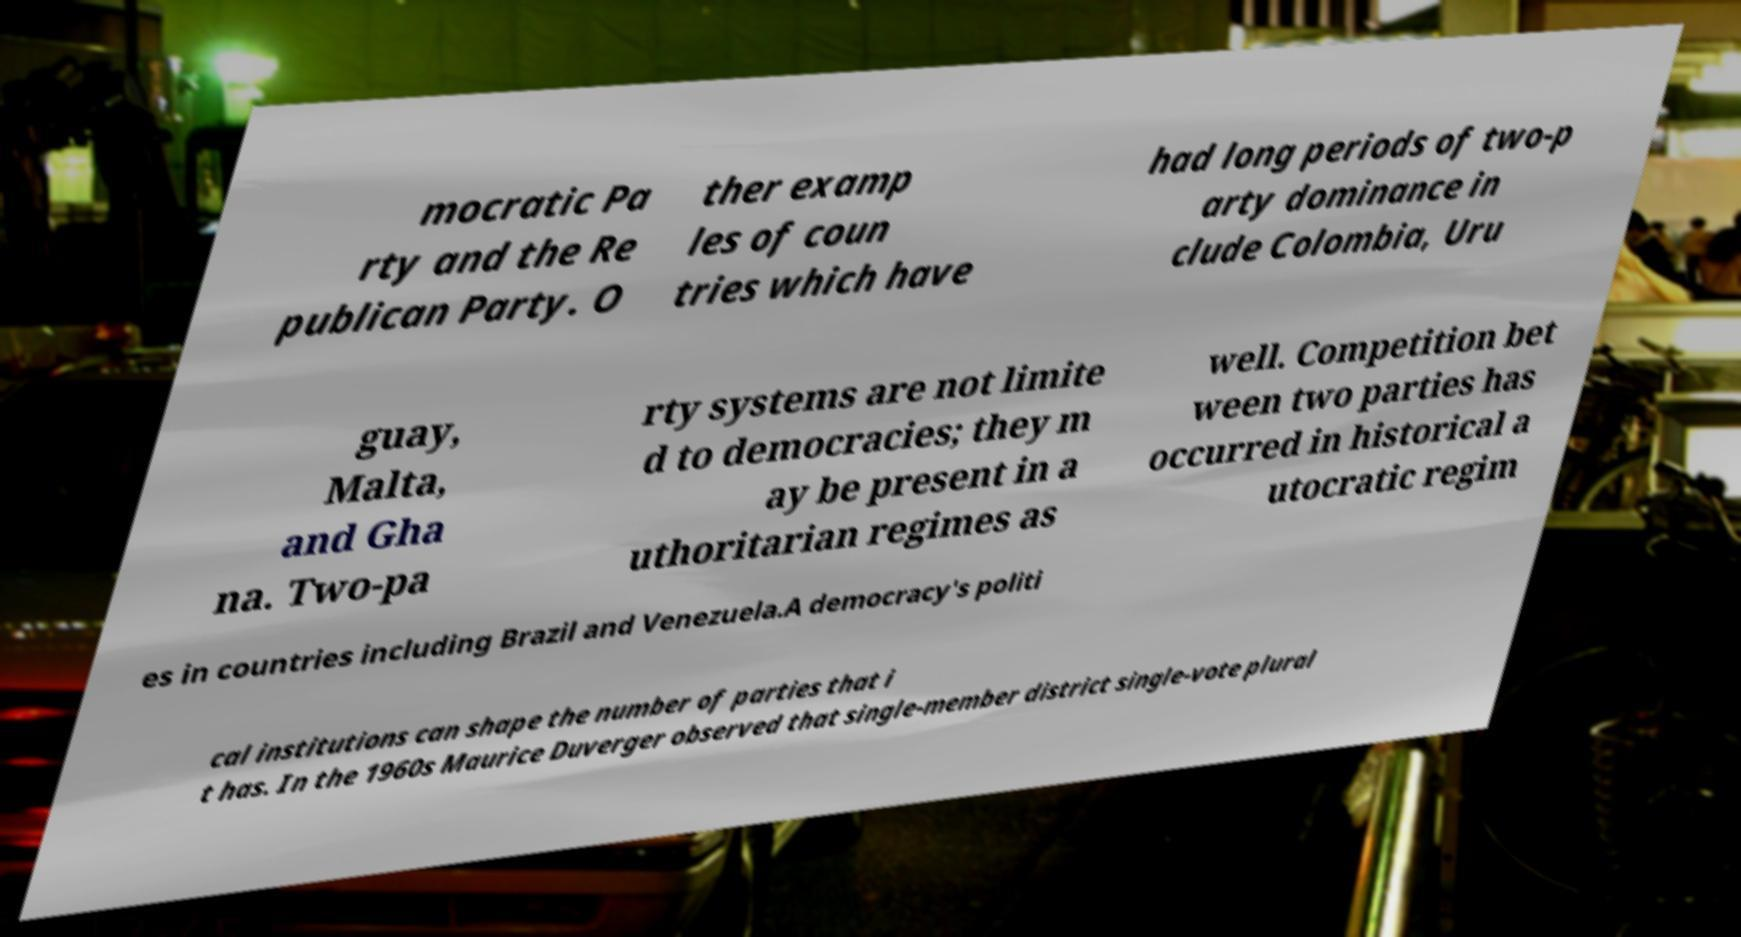Please read and relay the text visible in this image. What does it say? mocratic Pa rty and the Re publican Party. O ther examp les of coun tries which have had long periods of two-p arty dominance in clude Colombia, Uru guay, Malta, and Gha na. Two-pa rty systems are not limite d to democracies; they m ay be present in a uthoritarian regimes as well. Competition bet ween two parties has occurred in historical a utocratic regim es in countries including Brazil and Venezuela.A democracy's politi cal institutions can shape the number of parties that i t has. In the 1960s Maurice Duverger observed that single-member district single-vote plural 